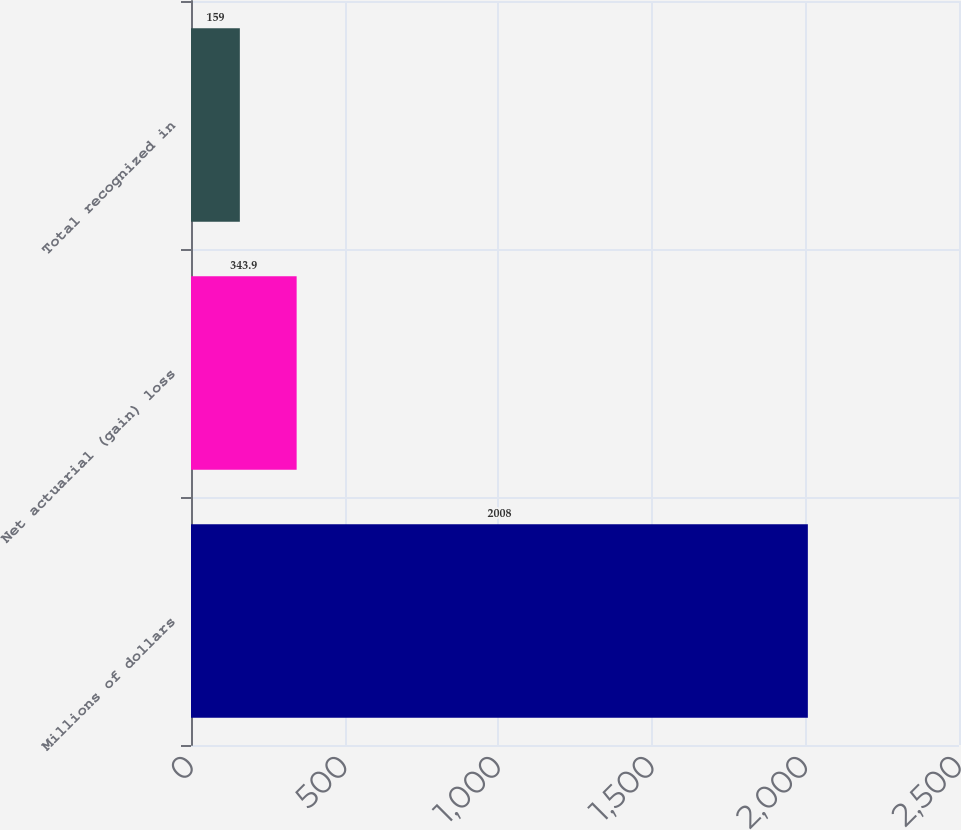Convert chart. <chart><loc_0><loc_0><loc_500><loc_500><bar_chart><fcel>Millions of dollars<fcel>Net actuarial (gain) loss<fcel>Total recognized in<nl><fcel>2008<fcel>343.9<fcel>159<nl></chart> 